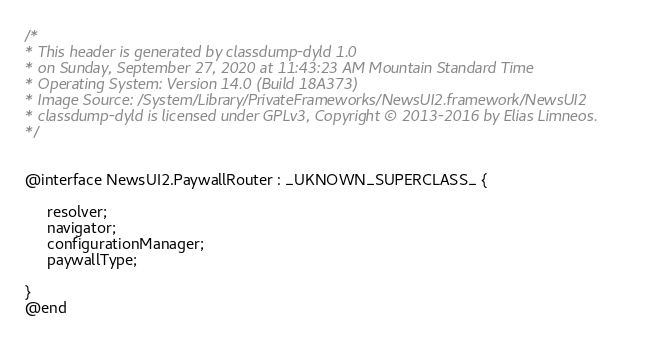Convert code to text. <code><loc_0><loc_0><loc_500><loc_500><_C_>/*
* This header is generated by classdump-dyld 1.0
* on Sunday, September 27, 2020 at 11:43:23 AM Mountain Standard Time
* Operating System: Version 14.0 (Build 18A373)
* Image Source: /System/Library/PrivateFrameworks/NewsUI2.framework/NewsUI2
* classdump-dyld is licensed under GPLv3, Copyright © 2013-2016 by Elias Limneos.
*/


@interface NewsUI2.PaywallRouter : _UKNOWN_SUPERCLASS_ {

	 resolver;
	 navigator;
	 configurationManager;
	 paywallType;

}
@end

</code> 